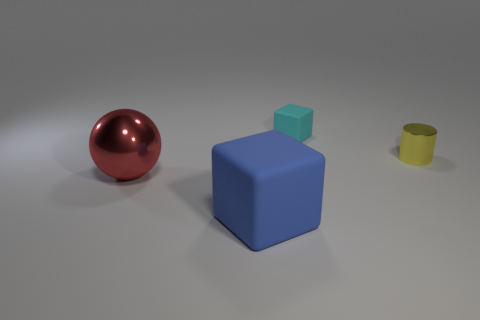Add 1 red spheres. How many objects exist? 5 Subtract all cylinders. How many objects are left? 3 Subtract 0 red cylinders. How many objects are left? 4 Subtract all brown metal spheres. Subtract all yellow metal cylinders. How many objects are left? 3 Add 4 cyan matte cubes. How many cyan matte cubes are left? 5 Add 4 blue things. How many blue things exist? 5 